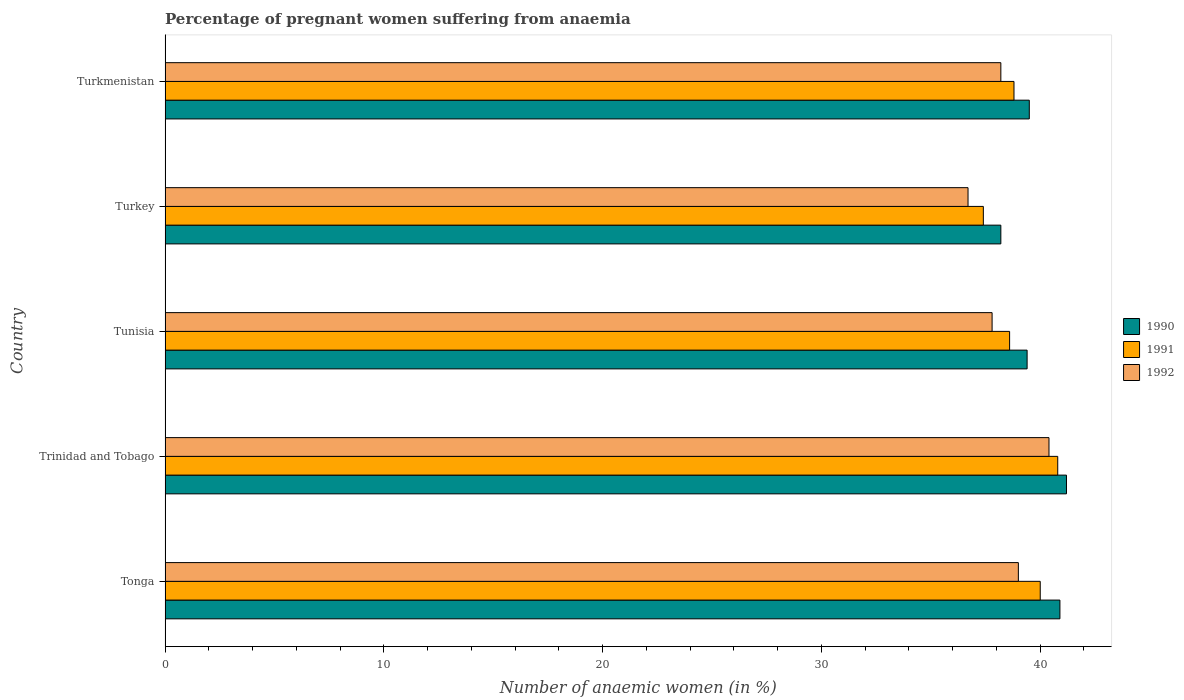How many different coloured bars are there?
Keep it short and to the point. 3. How many groups of bars are there?
Make the answer very short. 5. Are the number of bars on each tick of the Y-axis equal?
Offer a terse response. Yes. How many bars are there on the 5th tick from the top?
Give a very brief answer. 3. What is the label of the 5th group of bars from the top?
Provide a short and direct response. Tonga. What is the number of anaemic women in 1992 in Trinidad and Tobago?
Provide a short and direct response. 40.4. Across all countries, what is the maximum number of anaemic women in 1991?
Offer a terse response. 40.8. Across all countries, what is the minimum number of anaemic women in 1992?
Your answer should be compact. 36.7. In which country was the number of anaemic women in 1990 maximum?
Ensure brevity in your answer.  Trinidad and Tobago. What is the total number of anaemic women in 1990 in the graph?
Provide a succinct answer. 199.2. What is the difference between the number of anaemic women in 1991 in Tunisia and that in Turkey?
Your response must be concise. 1.2. What is the difference between the number of anaemic women in 1991 in Tonga and the number of anaemic women in 1992 in Trinidad and Tobago?
Give a very brief answer. -0.4. What is the average number of anaemic women in 1990 per country?
Provide a succinct answer. 39.84. What is the difference between the number of anaemic women in 1991 and number of anaemic women in 1992 in Trinidad and Tobago?
Offer a terse response. 0.4. What is the ratio of the number of anaemic women in 1991 in Tonga to that in Turkmenistan?
Provide a short and direct response. 1.03. Is the number of anaemic women in 1992 in Tonga less than that in Turkey?
Your response must be concise. No. What is the difference between the highest and the second highest number of anaemic women in 1990?
Offer a terse response. 0.3. Is the sum of the number of anaemic women in 1992 in Tunisia and Turkey greater than the maximum number of anaemic women in 1990 across all countries?
Offer a terse response. Yes. What does the 2nd bar from the bottom in Tunisia represents?
Keep it short and to the point. 1991. Is it the case that in every country, the sum of the number of anaemic women in 1992 and number of anaemic women in 1991 is greater than the number of anaemic women in 1990?
Make the answer very short. Yes. How many bars are there?
Make the answer very short. 15. What is the difference between two consecutive major ticks on the X-axis?
Your response must be concise. 10. Are the values on the major ticks of X-axis written in scientific E-notation?
Your answer should be very brief. No. How many legend labels are there?
Provide a succinct answer. 3. What is the title of the graph?
Give a very brief answer. Percentage of pregnant women suffering from anaemia. What is the label or title of the X-axis?
Your answer should be very brief. Number of anaemic women (in %). What is the Number of anaemic women (in %) in 1990 in Tonga?
Ensure brevity in your answer.  40.9. What is the Number of anaemic women (in %) of 1991 in Tonga?
Provide a succinct answer. 40. What is the Number of anaemic women (in %) in 1992 in Tonga?
Keep it short and to the point. 39. What is the Number of anaemic women (in %) in 1990 in Trinidad and Tobago?
Make the answer very short. 41.2. What is the Number of anaemic women (in %) in 1991 in Trinidad and Tobago?
Give a very brief answer. 40.8. What is the Number of anaemic women (in %) of 1992 in Trinidad and Tobago?
Keep it short and to the point. 40.4. What is the Number of anaemic women (in %) in 1990 in Tunisia?
Give a very brief answer. 39.4. What is the Number of anaemic women (in %) in 1991 in Tunisia?
Provide a short and direct response. 38.6. What is the Number of anaemic women (in %) of 1992 in Tunisia?
Give a very brief answer. 37.8. What is the Number of anaemic women (in %) in 1990 in Turkey?
Keep it short and to the point. 38.2. What is the Number of anaemic women (in %) in 1991 in Turkey?
Your answer should be compact. 37.4. What is the Number of anaemic women (in %) in 1992 in Turkey?
Provide a short and direct response. 36.7. What is the Number of anaemic women (in %) in 1990 in Turkmenistan?
Your answer should be compact. 39.5. What is the Number of anaemic women (in %) in 1991 in Turkmenistan?
Your response must be concise. 38.8. What is the Number of anaemic women (in %) of 1992 in Turkmenistan?
Offer a terse response. 38.2. Across all countries, what is the maximum Number of anaemic women (in %) in 1990?
Keep it short and to the point. 41.2. Across all countries, what is the maximum Number of anaemic women (in %) of 1991?
Provide a short and direct response. 40.8. Across all countries, what is the maximum Number of anaemic women (in %) in 1992?
Give a very brief answer. 40.4. Across all countries, what is the minimum Number of anaemic women (in %) in 1990?
Provide a short and direct response. 38.2. Across all countries, what is the minimum Number of anaemic women (in %) in 1991?
Make the answer very short. 37.4. Across all countries, what is the minimum Number of anaemic women (in %) in 1992?
Provide a short and direct response. 36.7. What is the total Number of anaemic women (in %) in 1990 in the graph?
Offer a very short reply. 199.2. What is the total Number of anaemic women (in %) of 1991 in the graph?
Offer a very short reply. 195.6. What is the total Number of anaemic women (in %) in 1992 in the graph?
Ensure brevity in your answer.  192.1. What is the difference between the Number of anaemic women (in %) of 1990 in Tonga and that in Trinidad and Tobago?
Ensure brevity in your answer.  -0.3. What is the difference between the Number of anaemic women (in %) of 1992 in Tonga and that in Trinidad and Tobago?
Your response must be concise. -1.4. What is the difference between the Number of anaemic women (in %) in 1990 in Tonga and that in Tunisia?
Your answer should be compact. 1.5. What is the difference between the Number of anaemic women (in %) in 1991 in Tonga and that in Tunisia?
Your answer should be very brief. 1.4. What is the difference between the Number of anaemic women (in %) of 1992 in Tonga and that in Tunisia?
Offer a very short reply. 1.2. What is the difference between the Number of anaemic women (in %) of 1991 in Tonga and that in Turkey?
Offer a terse response. 2.6. What is the difference between the Number of anaemic women (in %) of 1992 in Tonga and that in Turkey?
Ensure brevity in your answer.  2.3. What is the difference between the Number of anaemic women (in %) of 1992 in Tonga and that in Turkmenistan?
Provide a short and direct response. 0.8. What is the difference between the Number of anaemic women (in %) of 1991 in Trinidad and Tobago and that in Turkmenistan?
Make the answer very short. 2. What is the difference between the Number of anaemic women (in %) in 1992 in Trinidad and Tobago and that in Turkmenistan?
Make the answer very short. 2.2. What is the difference between the Number of anaemic women (in %) in 1991 in Tunisia and that in Turkey?
Offer a very short reply. 1.2. What is the difference between the Number of anaemic women (in %) in 1990 in Tunisia and that in Turkmenistan?
Ensure brevity in your answer.  -0.1. What is the difference between the Number of anaemic women (in %) in 1990 in Turkey and that in Turkmenistan?
Provide a succinct answer. -1.3. What is the difference between the Number of anaemic women (in %) in 1992 in Turkey and that in Turkmenistan?
Make the answer very short. -1.5. What is the difference between the Number of anaemic women (in %) in 1991 in Tonga and the Number of anaemic women (in %) in 1992 in Trinidad and Tobago?
Make the answer very short. -0.4. What is the difference between the Number of anaemic women (in %) of 1990 in Tonga and the Number of anaemic women (in %) of 1992 in Turkey?
Offer a very short reply. 4.2. What is the difference between the Number of anaemic women (in %) in 1991 in Tonga and the Number of anaemic women (in %) in 1992 in Turkey?
Offer a very short reply. 3.3. What is the difference between the Number of anaemic women (in %) of 1990 in Tonga and the Number of anaemic women (in %) of 1992 in Turkmenistan?
Your response must be concise. 2.7. What is the difference between the Number of anaemic women (in %) in 1991 in Tonga and the Number of anaemic women (in %) in 1992 in Turkmenistan?
Make the answer very short. 1.8. What is the difference between the Number of anaemic women (in %) of 1990 in Trinidad and Tobago and the Number of anaemic women (in %) of 1992 in Tunisia?
Your answer should be compact. 3.4. What is the difference between the Number of anaemic women (in %) of 1990 in Trinidad and Tobago and the Number of anaemic women (in %) of 1991 in Turkey?
Your answer should be compact. 3.8. What is the difference between the Number of anaemic women (in %) in 1990 in Trinidad and Tobago and the Number of anaemic women (in %) in 1992 in Turkmenistan?
Provide a succinct answer. 3. What is the difference between the Number of anaemic women (in %) of 1990 in Tunisia and the Number of anaemic women (in %) of 1991 in Turkey?
Provide a succinct answer. 2. What is the difference between the Number of anaemic women (in %) in 1990 in Tunisia and the Number of anaemic women (in %) in 1991 in Turkmenistan?
Provide a short and direct response. 0.6. What is the difference between the Number of anaemic women (in %) of 1991 in Tunisia and the Number of anaemic women (in %) of 1992 in Turkmenistan?
Offer a very short reply. 0.4. What is the difference between the Number of anaemic women (in %) of 1990 in Turkey and the Number of anaemic women (in %) of 1991 in Turkmenistan?
Your answer should be very brief. -0.6. What is the average Number of anaemic women (in %) of 1990 per country?
Your response must be concise. 39.84. What is the average Number of anaemic women (in %) in 1991 per country?
Your response must be concise. 39.12. What is the average Number of anaemic women (in %) in 1992 per country?
Offer a very short reply. 38.42. What is the difference between the Number of anaemic women (in %) in 1990 and Number of anaemic women (in %) in 1991 in Tonga?
Your answer should be compact. 0.9. What is the difference between the Number of anaemic women (in %) in 1990 and Number of anaemic women (in %) in 1992 in Tonga?
Offer a terse response. 1.9. What is the difference between the Number of anaemic women (in %) of 1991 and Number of anaemic women (in %) of 1992 in Tonga?
Ensure brevity in your answer.  1. What is the difference between the Number of anaemic women (in %) of 1990 and Number of anaemic women (in %) of 1991 in Trinidad and Tobago?
Make the answer very short. 0.4. What is the difference between the Number of anaemic women (in %) of 1990 and Number of anaemic women (in %) of 1992 in Tunisia?
Make the answer very short. 1.6. What is the difference between the Number of anaemic women (in %) of 1990 and Number of anaemic women (in %) of 1991 in Turkey?
Your answer should be compact. 0.8. What is the difference between the Number of anaemic women (in %) of 1990 and Number of anaemic women (in %) of 1991 in Turkmenistan?
Your answer should be compact. 0.7. What is the difference between the Number of anaemic women (in %) of 1990 and Number of anaemic women (in %) of 1992 in Turkmenistan?
Your answer should be compact. 1.3. What is the ratio of the Number of anaemic women (in %) of 1990 in Tonga to that in Trinidad and Tobago?
Your answer should be compact. 0.99. What is the ratio of the Number of anaemic women (in %) of 1991 in Tonga to that in Trinidad and Tobago?
Your response must be concise. 0.98. What is the ratio of the Number of anaemic women (in %) in 1992 in Tonga to that in Trinidad and Tobago?
Your answer should be very brief. 0.97. What is the ratio of the Number of anaemic women (in %) of 1990 in Tonga to that in Tunisia?
Your answer should be compact. 1.04. What is the ratio of the Number of anaemic women (in %) of 1991 in Tonga to that in Tunisia?
Make the answer very short. 1.04. What is the ratio of the Number of anaemic women (in %) in 1992 in Tonga to that in Tunisia?
Ensure brevity in your answer.  1.03. What is the ratio of the Number of anaemic women (in %) of 1990 in Tonga to that in Turkey?
Offer a very short reply. 1.07. What is the ratio of the Number of anaemic women (in %) in 1991 in Tonga to that in Turkey?
Keep it short and to the point. 1.07. What is the ratio of the Number of anaemic women (in %) of 1992 in Tonga to that in Turkey?
Your response must be concise. 1.06. What is the ratio of the Number of anaemic women (in %) of 1990 in Tonga to that in Turkmenistan?
Your response must be concise. 1.04. What is the ratio of the Number of anaemic women (in %) in 1991 in Tonga to that in Turkmenistan?
Ensure brevity in your answer.  1.03. What is the ratio of the Number of anaemic women (in %) of 1992 in Tonga to that in Turkmenistan?
Offer a very short reply. 1.02. What is the ratio of the Number of anaemic women (in %) in 1990 in Trinidad and Tobago to that in Tunisia?
Your answer should be very brief. 1.05. What is the ratio of the Number of anaemic women (in %) in 1991 in Trinidad and Tobago to that in Tunisia?
Your answer should be compact. 1.06. What is the ratio of the Number of anaemic women (in %) in 1992 in Trinidad and Tobago to that in Tunisia?
Keep it short and to the point. 1.07. What is the ratio of the Number of anaemic women (in %) in 1990 in Trinidad and Tobago to that in Turkey?
Provide a short and direct response. 1.08. What is the ratio of the Number of anaemic women (in %) of 1992 in Trinidad and Tobago to that in Turkey?
Provide a short and direct response. 1.1. What is the ratio of the Number of anaemic women (in %) of 1990 in Trinidad and Tobago to that in Turkmenistan?
Make the answer very short. 1.04. What is the ratio of the Number of anaemic women (in %) in 1991 in Trinidad and Tobago to that in Turkmenistan?
Give a very brief answer. 1.05. What is the ratio of the Number of anaemic women (in %) of 1992 in Trinidad and Tobago to that in Turkmenistan?
Your response must be concise. 1.06. What is the ratio of the Number of anaemic women (in %) in 1990 in Tunisia to that in Turkey?
Your answer should be very brief. 1.03. What is the ratio of the Number of anaemic women (in %) in 1991 in Tunisia to that in Turkey?
Ensure brevity in your answer.  1.03. What is the ratio of the Number of anaemic women (in %) of 1992 in Tunisia to that in Turkmenistan?
Your answer should be very brief. 0.99. What is the ratio of the Number of anaemic women (in %) of 1990 in Turkey to that in Turkmenistan?
Provide a short and direct response. 0.97. What is the ratio of the Number of anaemic women (in %) in 1991 in Turkey to that in Turkmenistan?
Your response must be concise. 0.96. What is the ratio of the Number of anaemic women (in %) in 1992 in Turkey to that in Turkmenistan?
Your answer should be compact. 0.96. What is the difference between the highest and the lowest Number of anaemic women (in %) of 1991?
Make the answer very short. 3.4. 